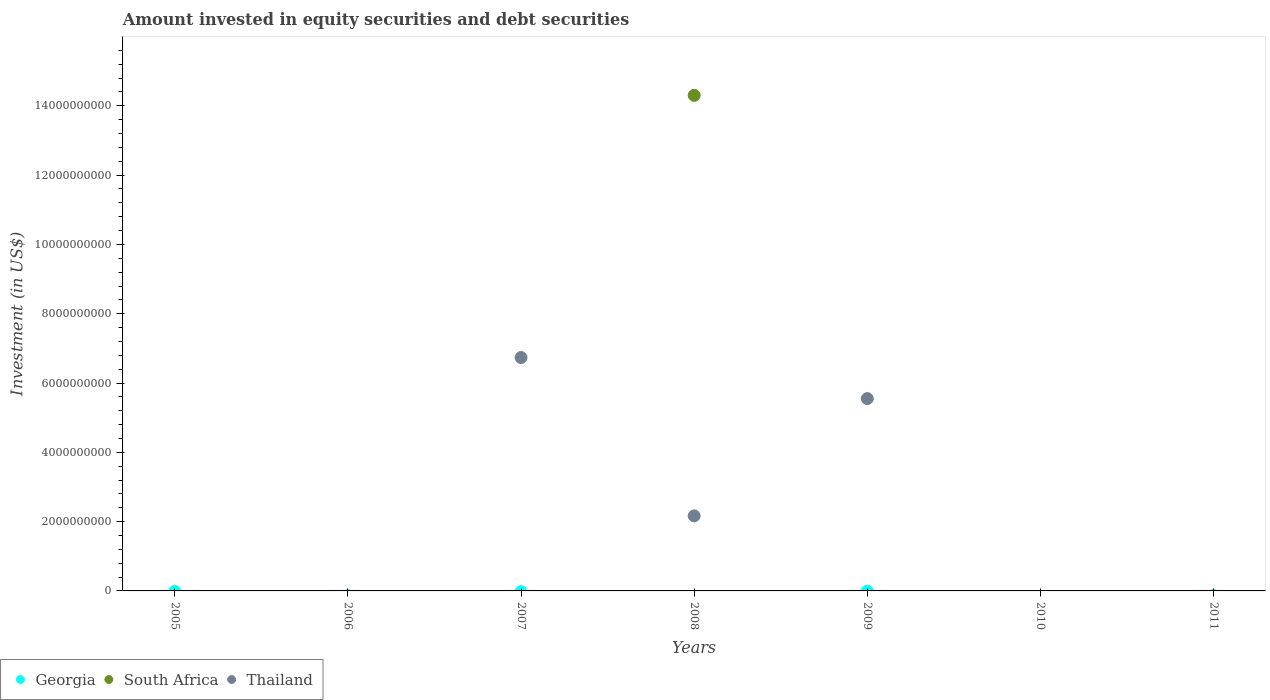How many different coloured dotlines are there?
Your response must be concise. 2. Is the number of dotlines equal to the number of legend labels?
Your response must be concise. No. What is the amount invested in equity securities and debt securities in Georgia in 2007?
Your response must be concise. 0. Across all years, what is the maximum amount invested in equity securities and debt securities in South Africa?
Provide a succinct answer. 1.43e+1. Across all years, what is the minimum amount invested in equity securities and debt securities in Thailand?
Your answer should be compact. 0. In which year was the amount invested in equity securities and debt securities in Thailand maximum?
Keep it short and to the point. 2007. What is the total amount invested in equity securities and debt securities in Thailand in the graph?
Your response must be concise. 1.45e+1. What is the difference between the amount invested in equity securities and debt securities in Georgia in 2005 and the amount invested in equity securities and debt securities in Thailand in 2009?
Make the answer very short. -5.55e+09. In how many years, is the amount invested in equity securities and debt securities in Georgia greater than 6000000000 US$?
Give a very brief answer. 0. What is the difference between the highest and the lowest amount invested in equity securities and debt securities in Thailand?
Provide a short and direct response. 6.74e+09. Does the amount invested in equity securities and debt securities in Georgia monotonically increase over the years?
Keep it short and to the point. No. Is the amount invested in equity securities and debt securities in Georgia strictly less than the amount invested in equity securities and debt securities in Thailand over the years?
Your answer should be very brief. No. What is the difference between two consecutive major ticks on the Y-axis?
Your response must be concise. 2.00e+09. Where does the legend appear in the graph?
Ensure brevity in your answer.  Bottom left. How many legend labels are there?
Make the answer very short. 3. What is the title of the graph?
Provide a short and direct response. Amount invested in equity securities and debt securities. Does "Peru" appear as one of the legend labels in the graph?
Offer a terse response. No. What is the label or title of the X-axis?
Offer a very short reply. Years. What is the label or title of the Y-axis?
Provide a short and direct response. Investment (in US$). What is the Investment (in US$) in South Africa in 2005?
Your answer should be compact. 0. What is the Investment (in US$) of Georgia in 2006?
Provide a short and direct response. 0. What is the Investment (in US$) of Thailand in 2006?
Make the answer very short. 0. What is the Investment (in US$) of South Africa in 2007?
Provide a succinct answer. 0. What is the Investment (in US$) of Thailand in 2007?
Your response must be concise. 6.74e+09. What is the Investment (in US$) in Georgia in 2008?
Provide a succinct answer. 0. What is the Investment (in US$) in South Africa in 2008?
Your answer should be very brief. 1.43e+1. What is the Investment (in US$) of Thailand in 2008?
Provide a short and direct response. 2.17e+09. What is the Investment (in US$) of South Africa in 2009?
Keep it short and to the point. 0. What is the Investment (in US$) in Thailand in 2009?
Your answer should be compact. 5.55e+09. What is the Investment (in US$) in Georgia in 2010?
Your answer should be compact. 0. What is the Investment (in US$) of Thailand in 2010?
Ensure brevity in your answer.  0. What is the Investment (in US$) in Thailand in 2011?
Provide a short and direct response. 0. Across all years, what is the maximum Investment (in US$) of South Africa?
Keep it short and to the point. 1.43e+1. Across all years, what is the maximum Investment (in US$) in Thailand?
Provide a short and direct response. 6.74e+09. Across all years, what is the minimum Investment (in US$) of Thailand?
Make the answer very short. 0. What is the total Investment (in US$) of South Africa in the graph?
Provide a short and direct response. 1.43e+1. What is the total Investment (in US$) of Thailand in the graph?
Make the answer very short. 1.45e+1. What is the difference between the Investment (in US$) of Thailand in 2007 and that in 2008?
Keep it short and to the point. 4.57e+09. What is the difference between the Investment (in US$) of Thailand in 2007 and that in 2009?
Give a very brief answer. 1.19e+09. What is the difference between the Investment (in US$) of Thailand in 2008 and that in 2009?
Offer a very short reply. -3.39e+09. What is the difference between the Investment (in US$) in South Africa in 2008 and the Investment (in US$) in Thailand in 2009?
Your answer should be very brief. 8.75e+09. What is the average Investment (in US$) of Georgia per year?
Your answer should be very brief. 0. What is the average Investment (in US$) in South Africa per year?
Provide a short and direct response. 2.04e+09. What is the average Investment (in US$) in Thailand per year?
Your answer should be compact. 2.06e+09. In the year 2008, what is the difference between the Investment (in US$) in South Africa and Investment (in US$) in Thailand?
Provide a short and direct response. 1.21e+1. What is the ratio of the Investment (in US$) in Thailand in 2007 to that in 2008?
Provide a short and direct response. 3.11. What is the ratio of the Investment (in US$) of Thailand in 2007 to that in 2009?
Give a very brief answer. 1.21. What is the ratio of the Investment (in US$) of Thailand in 2008 to that in 2009?
Offer a terse response. 0.39. What is the difference between the highest and the second highest Investment (in US$) in Thailand?
Provide a succinct answer. 1.19e+09. What is the difference between the highest and the lowest Investment (in US$) of South Africa?
Your answer should be very brief. 1.43e+1. What is the difference between the highest and the lowest Investment (in US$) in Thailand?
Provide a succinct answer. 6.74e+09. 